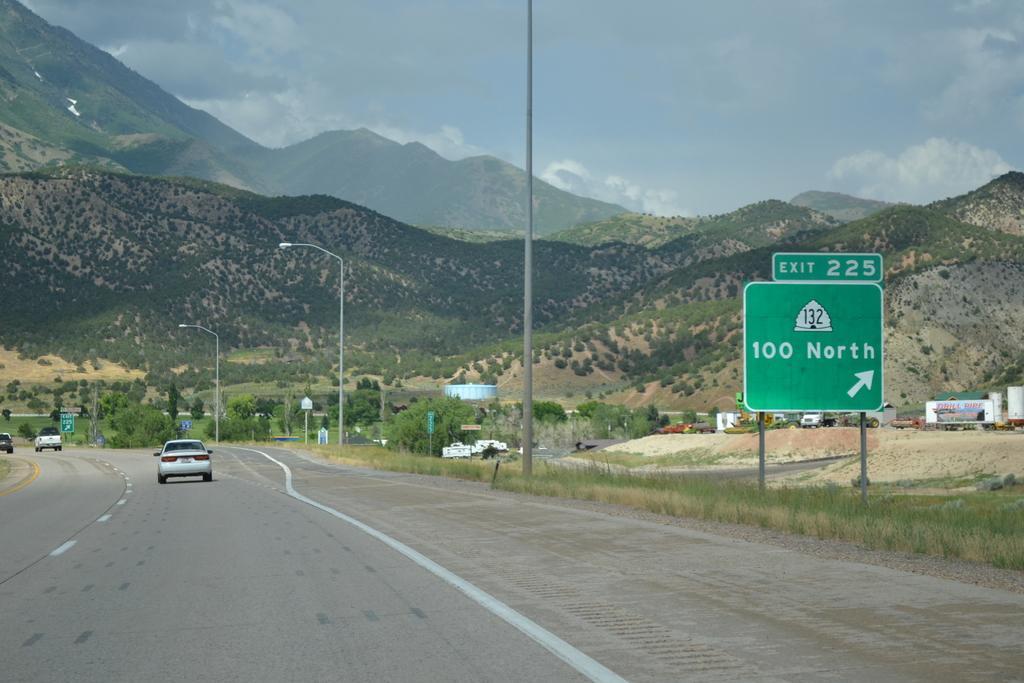In one or two sentences, can you explain what this image depicts? In this image we can see the hills, trees, sign boards and also light poles. We can also see the vehicles passing on the road. There is sky with the clouds. Grass is also visible. 